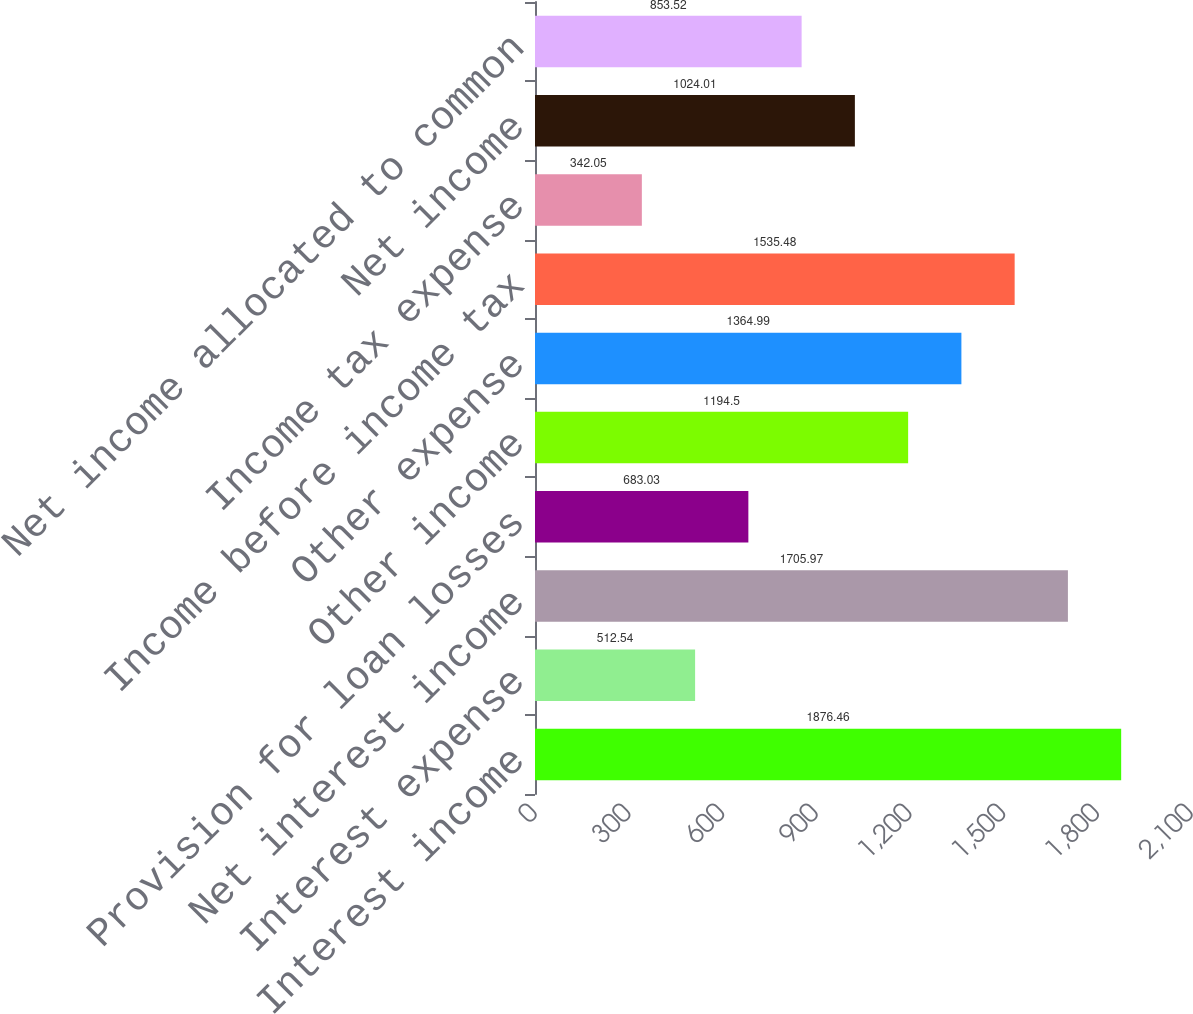Convert chart to OTSL. <chart><loc_0><loc_0><loc_500><loc_500><bar_chart><fcel>Interest income<fcel>Interest expense<fcel>Net interest income<fcel>Provision for loan losses<fcel>Other income<fcel>Other expense<fcel>Income before income tax<fcel>Income tax expense<fcel>Net income<fcel>Net income allocated to common<nl><fcel>1876.46<fcel>512.54<fcel>1705.97<fcel>683.03<fcel>1194.5<fcel>1364.99<fcel>1535.48<fcel>342.05<fcel>1024.01<fcel>853.52<nl></chart> 